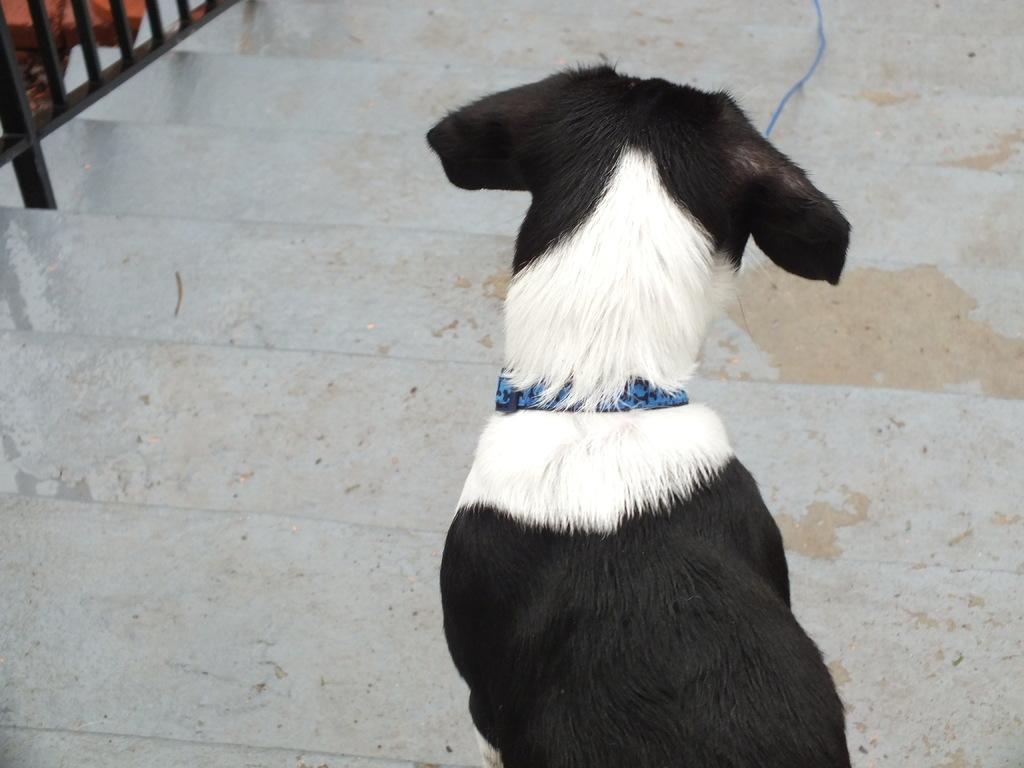Could you give a brief overview of what you see in this image? In the picture there is a black and white dog on the steps and there is a blue chain tied around the dog´s neck. 